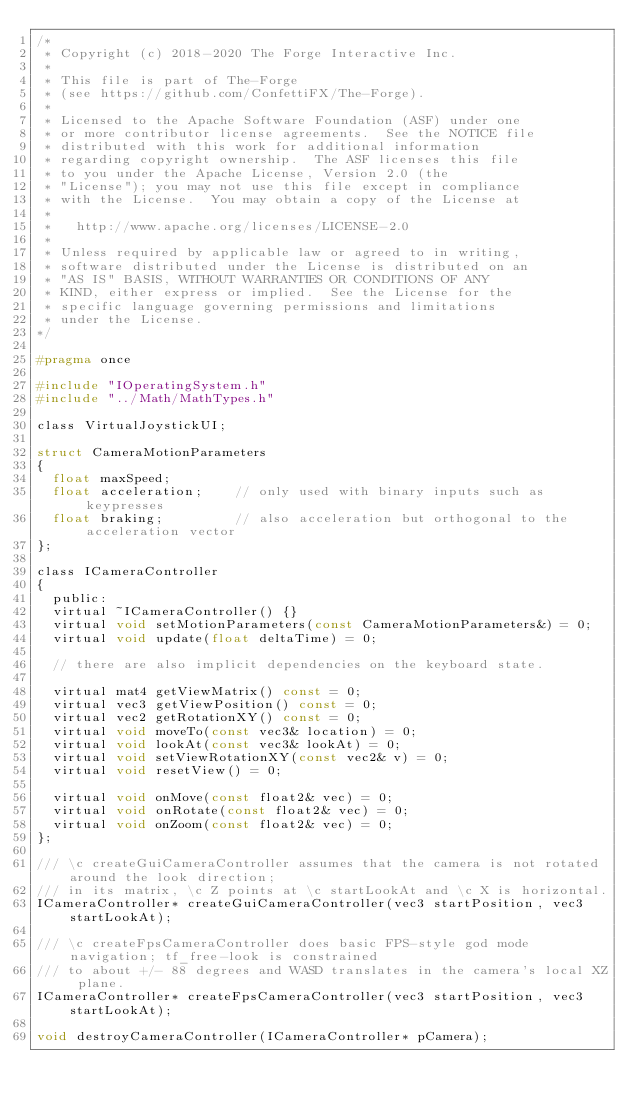Convert code to text. <code><loc_0><loc_0><loc_500><loc_500><_C_>/*
 * Copyright (c) 2018-2020 The Forge Interactive Inc.
 *
 * This file is part of The-Forge
 * (see https://github.com/ConfettiFX/The-Forge).
 *
 * Licensed to the Apache Software Foundation (ASF) under one
 * or more contributor license agreements.  See the NOTICE file
 * distributed with this work for additional information
 * regarding copyright ownership.  The ASF licenses this file
 * to you under the Apache License, Version 2.0 (the
 * "License"); you may not use this file except in compliance
 * with the License.  You may obtain a copy of the License at
 *
 *   http://www.apache.org/licenses/LICENSE-2.0
 *
 * Unless required by applicable law or agreed to in writing,
 * software distributed under the License is distributed on an
 * "AS IS" BASIS, WITHOUT WARRANTIES OR CONDITIONS OF ANY
 * KIND, either express or implied.  See the License for the
 * specific language governing permissions and limitations
 * under the License.
*/

#pragma once

#include "IOperatingSystem.h"
#include "../Math/MathTypes.h"

class VirtualJoystickUI;

struct CameraMotionParameters
{
	float maxSpeed;
	float acceleration;    // only used with binary inputs such as keypresses
	float braking;         // also acceleration but orthogonal to the acceleration vector
};

class ICameraController
{
	public:
	virtual ~ICameraController() {}
	virtual void setMotionParameters(const CameraMotionParameters&) = 0;
	virtual void update(float deltaTime) = 0;

	// there are also implicit dependencies on the keyboard state.

	virtual mat4 getViewMatrix() const = 0;
	virtual vec3 getViewPosition() const = 0;
	virtual vec2 getRotationXY() const = 0;
	virtual void moveTo(const vec3& location) = 0;
	virtual void lookAt(const vec3& lookAt) = 0;
	virtual void setViewRotationXY(const vec2& v) = 0;
	virtual void resetView() = 0;

	virtual void onMove(const float2& vec) = 0;
	virtual void onRotate(const float2& vec) = 0;
	virtual void onZoom(const float2& vec) = 0;
};

/// \c createGuiCameraController assumes that the camera is not rotated around the look direction;
/// in its matrix, \c Z points at \c startLookAt and \c X is horizontal.
ICameraController* createGuiCameraController(vec3 startPosition, vec3 startLookAt);

/// \c createFpsCameraController does basic FPS-style god mode navigation; tf_free-look is constrained
/// to about +/- 88 degrees and WASD translates in the camera's local XZ plane.
ICameraController* createFpsCameraController(vec3 startPosition, vec3 startLookAt);

void destroyCameraController(ICameraController* pCamera);
</code> 